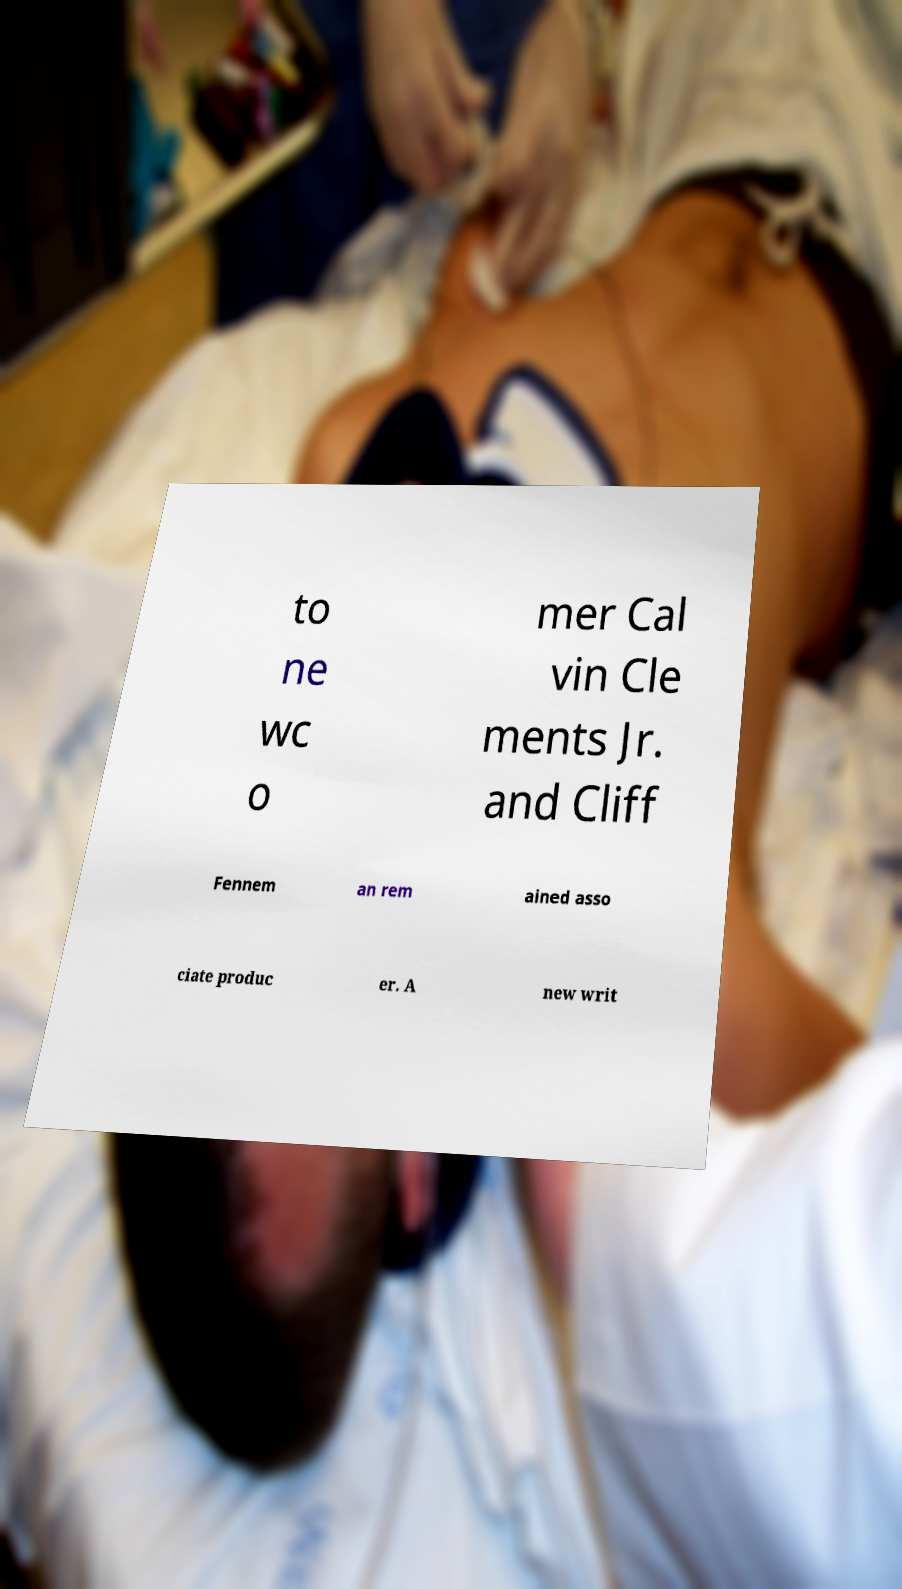Please identify and transcribe the text found in this image. to ne wc o mer Cal vin Cle ments Jr. and Cliff Fennem an rem ained asso ciate produc er. A new writ 